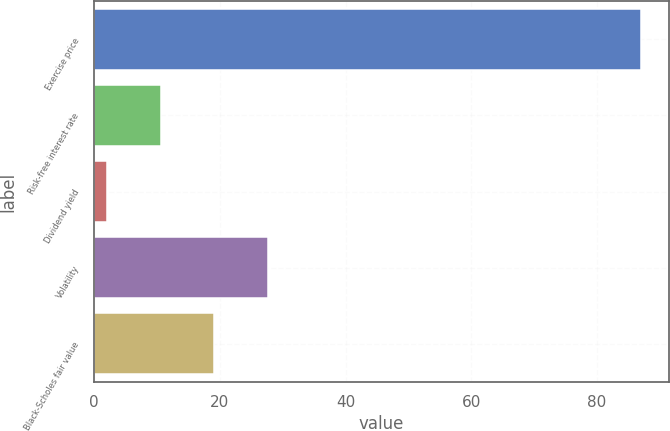<chart> <loc_0><loc_0><loc_500><loc_500><bar_chart><fcel>Exercise price<fcel>Risk-free interest rate<fcel>Dividend yield<fcel>Volatility<fcel>Black-Scholes fair value<nl><fcel>87.12<fcel>10.6<fcel>2.1<fcel>27.6<fcel>19.1<nl></chart> 